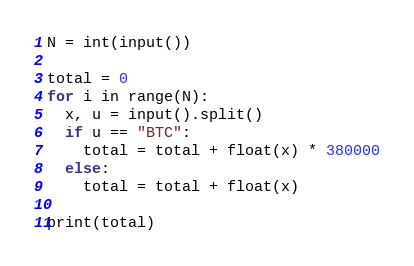Convert code to text. <code><loc_0><loc_0><loc_500><loc_500><_Python_>N = int(input())

total = 0
for i in range(N):
  x, u = input().split()
  if u == "BTC":
    total = total + float(x) * 380000
  else:
    total = total + float(x)

print(total)</code> 